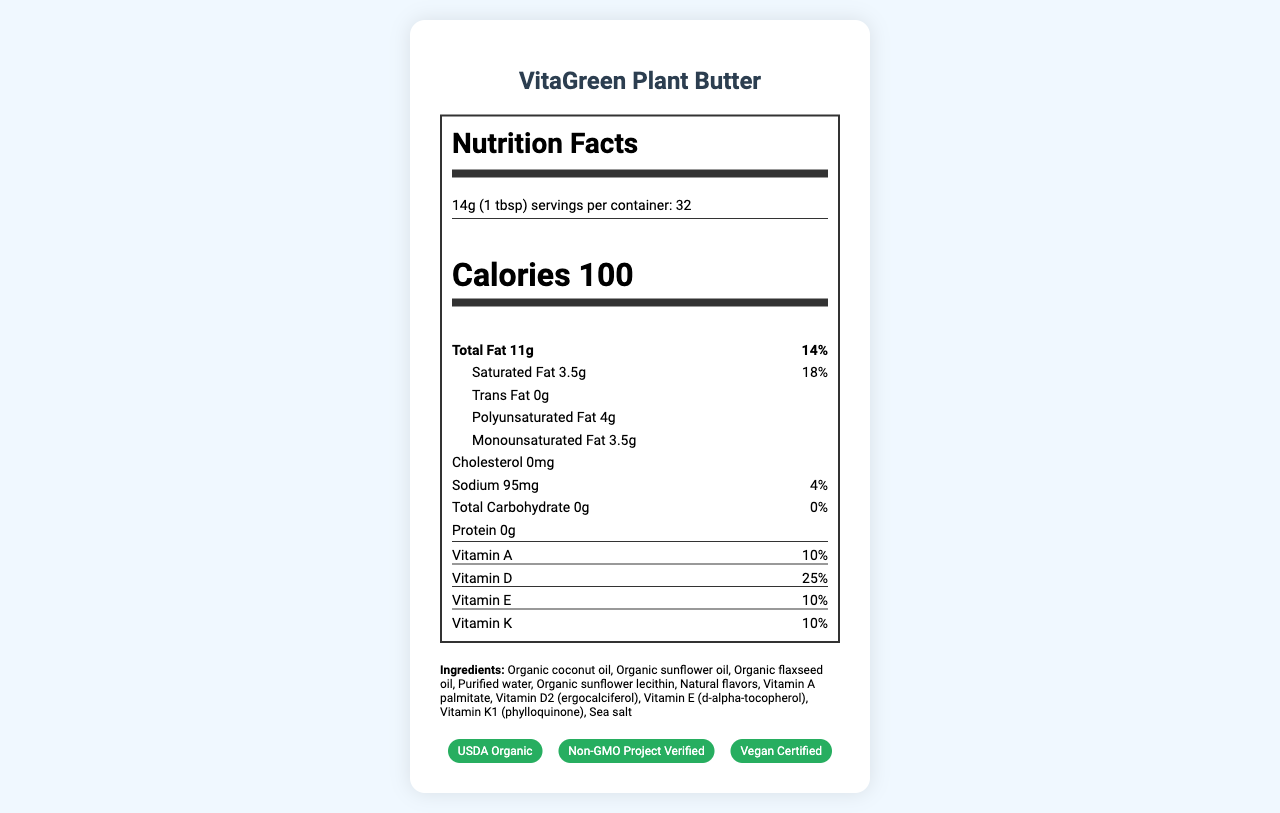What is the serving size of the VitaGreen Plant Butter? The document lists the serving size as 14 grams or 1 tablespoon.
Answer: 14g (1 tbsp) How many servings are there per container? According to the label, there are 32 servings per container.
Answer: 32 What is the amount of saturated fat per serving? The document specifies that each serving contains 3.5 grams of saturated fat.
Answer: 3.5g What is the daily value percentage of Vitamin D per serving? The document shows that each serving provides 100 IU of Vitamin D, which is 25% of the daily value.
Answer: 25% How much Omega-3 fatty acid does the VitaGreen Plant Butter contain per serving? The fatty acid profile indicates that the product contains 1.5 grams of Omega-3 per serving.
Answer: 1.5g How many calories are there per serving? The nutrition label states there are 100 calories in each serving.
Answer: 100 Does the product contain any cholesterol? The document explicitly states that the cholesterol content is 0mg.
Answer: No What is the main ingredient of VitaGreen Plant Butter? A. Organic coconut oil B. Organic sunflower oil C. Organic flaxseed oil The document lists "Organic coconut oil" as the first ingredient, indicating it is the main ingredient.
Answer: A Which vitamin has the highest daily value percentage? A. Vitamin A B. Vitamin D C. Vitamin E D. Vitamin K Vitamin D has the highest daily value percentage at 25%.
Answer: B Does the VitaGreen Plant Butter contain any trans fat? The document specifies that the trans fat content is 0g.
Answer: No Can you summarize the key nutritional information of VitaGreen Plant Butter? The VitaGreen Plant Butter is a plant-based product focused on providing healthy fats and essential vitamins while being free from cholesterol and trans fats. The organic ingredients and various certifications emphasize its health and quality standards.
Answer: VitaGreen Plant Butter provides 100 calories per serving, with a significant content of healthy fats, including polyunsaturated and monounsaturated fats. It is fortified with vitamins A, D, E, and K, with notable percentages of daily values for these vitamins. It does not contain any cholesterol or trans fats, and its ingredients include a variety of organic oils and lecithin. What is the source of Vitamin D in the product? While the label specifies that vitamin D2 (ergocalciferol) is used, it doesn't provide details about its specific source.
Answer: Not enough information What certifications does VitaGreen Plant Butter have? The document lists these three certifications in the certifications section.
Answer: USDA Organic, Non-GMO Project Verified, Vegan Certified How much sodium is present per serving, and what is its daily value percentage? The document states that there are 95mg of sodium per serving, which corresponds to 4% of the daily value.
Answer: 95mg, 4% 